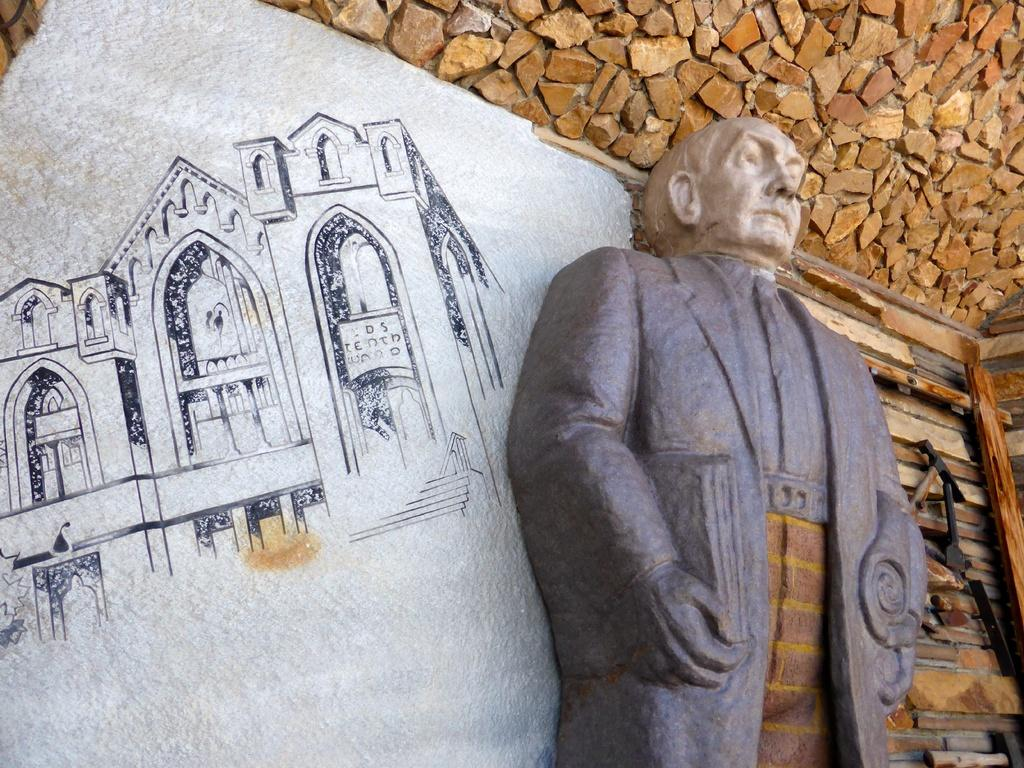What is the main subject in the image? There is a person statue in the image. What is behind the statue? There is a rock wall behind the statue. What is depicted on the left side of the wall? A building picture is painted on the left side of the wall. What can be seen on the right side of the wall? There are objects on the right side of the wall. How many stars are visible on the person statue in the image? There are no stars visible on the person statue in the image. What books are the person statue holding in the image? The person statue is not holding any books in the image. 